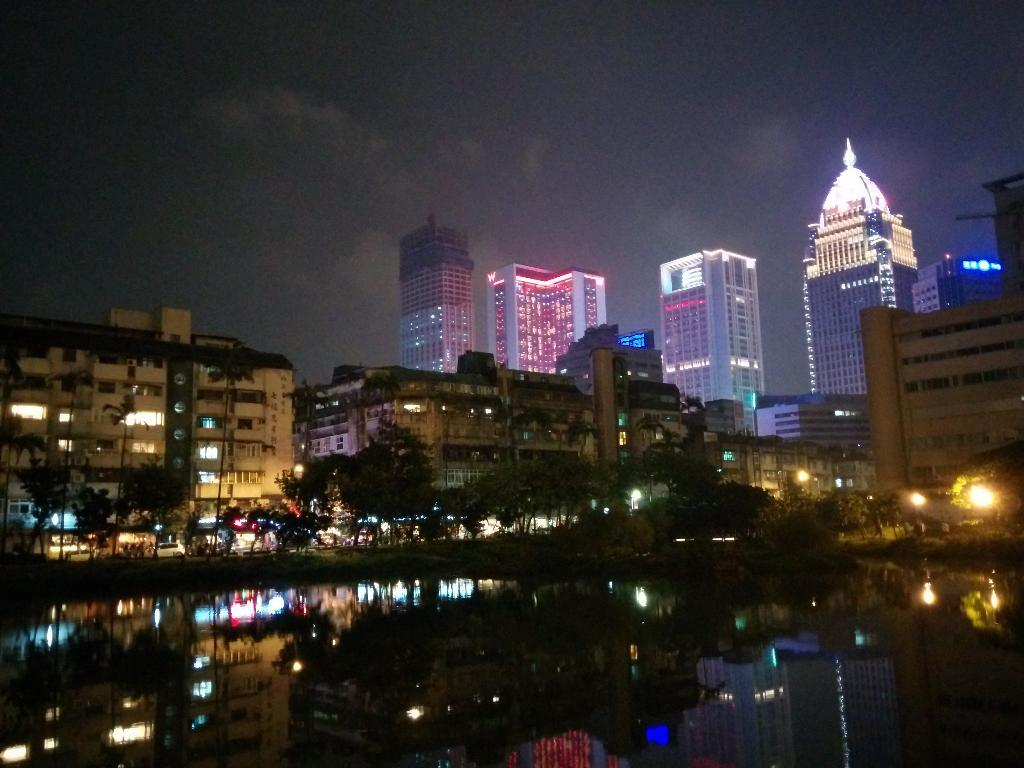What is present at the bottom of the image? There is water at the bottom of the image. What can be seen in the background of the image? There are buildings, trees, and lights in the background of the image. What is visible at the top of the image? The sky is visible at the top of the image. What type of authority is depicted in the image? There is no authority figure present in the image; it primarily features water, buildings, trees, lights, and the sky. Can you describe the picture within the picture in the image? There is no picture within the picture in the image; it only contains the water, buildings, trees, lights, and sky. 